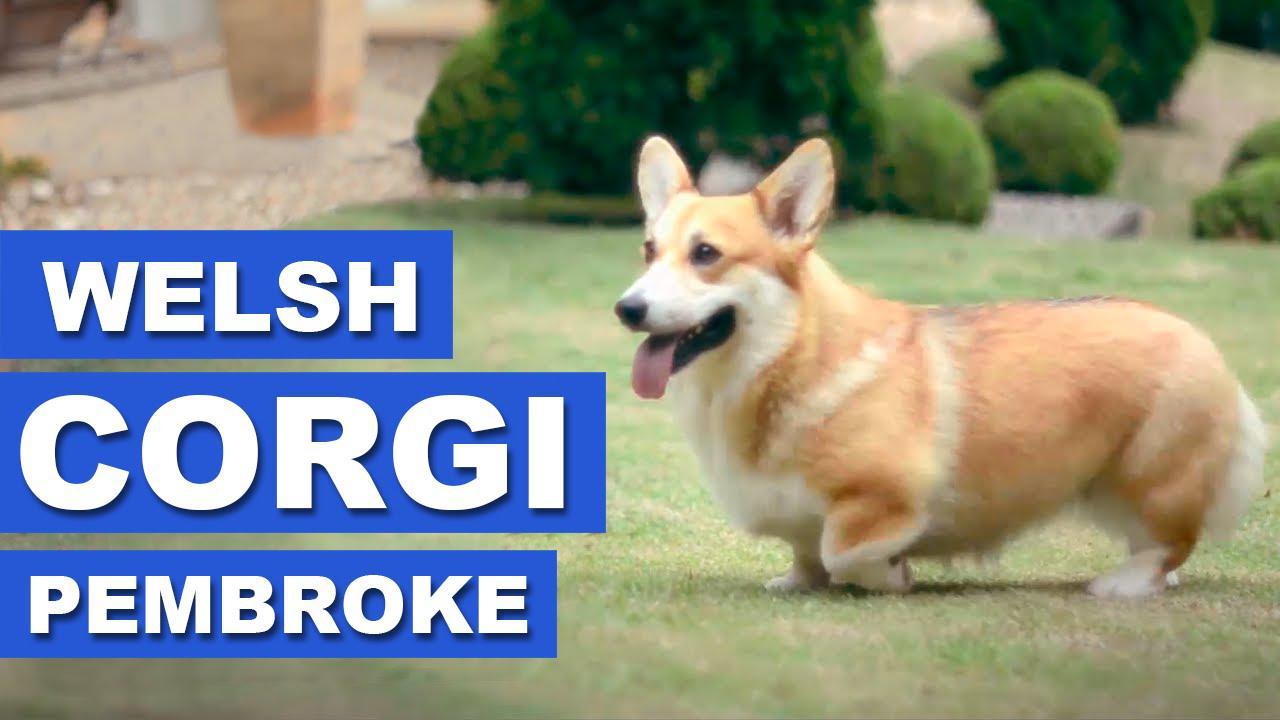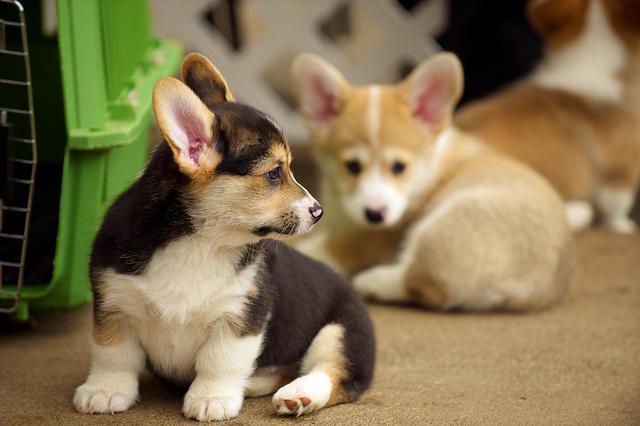The first image is the image on the left, the second image is the image on the right. Evaluate the accuracy of this statement regarding the images: "In at least one image there are three dog sitting next to each other in the grass.". Is it true? Answer yes or no. No. 